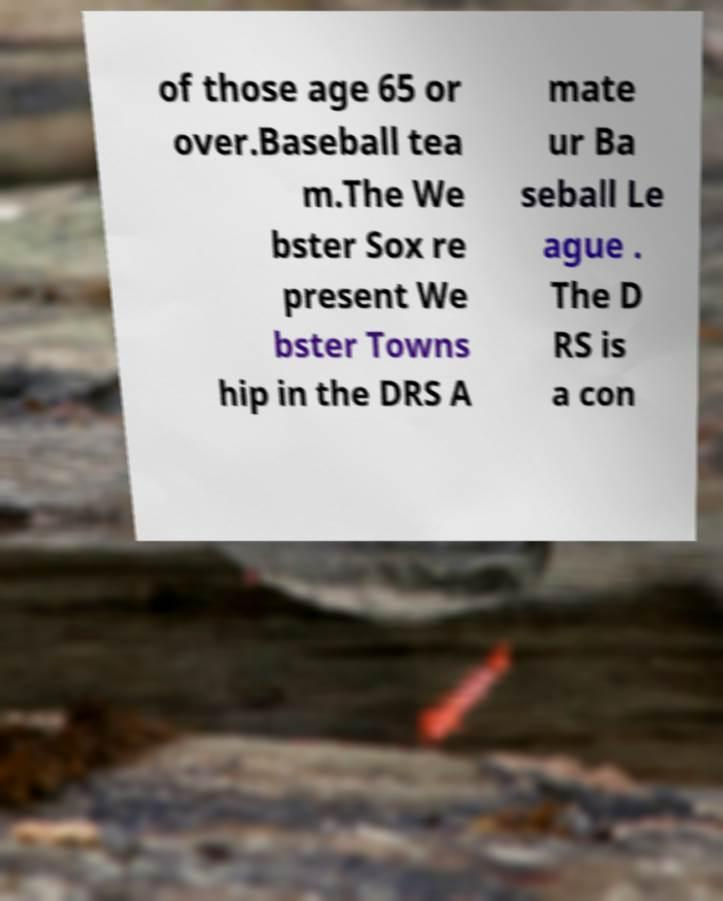I need the written content from this picture converted into text. Can you do that? of those age 65 or over.Baseball tea m.The We bster Sox re present We bster Towns hip in the DRS A mate ur Ba seball Le ague . The D RS is a con 